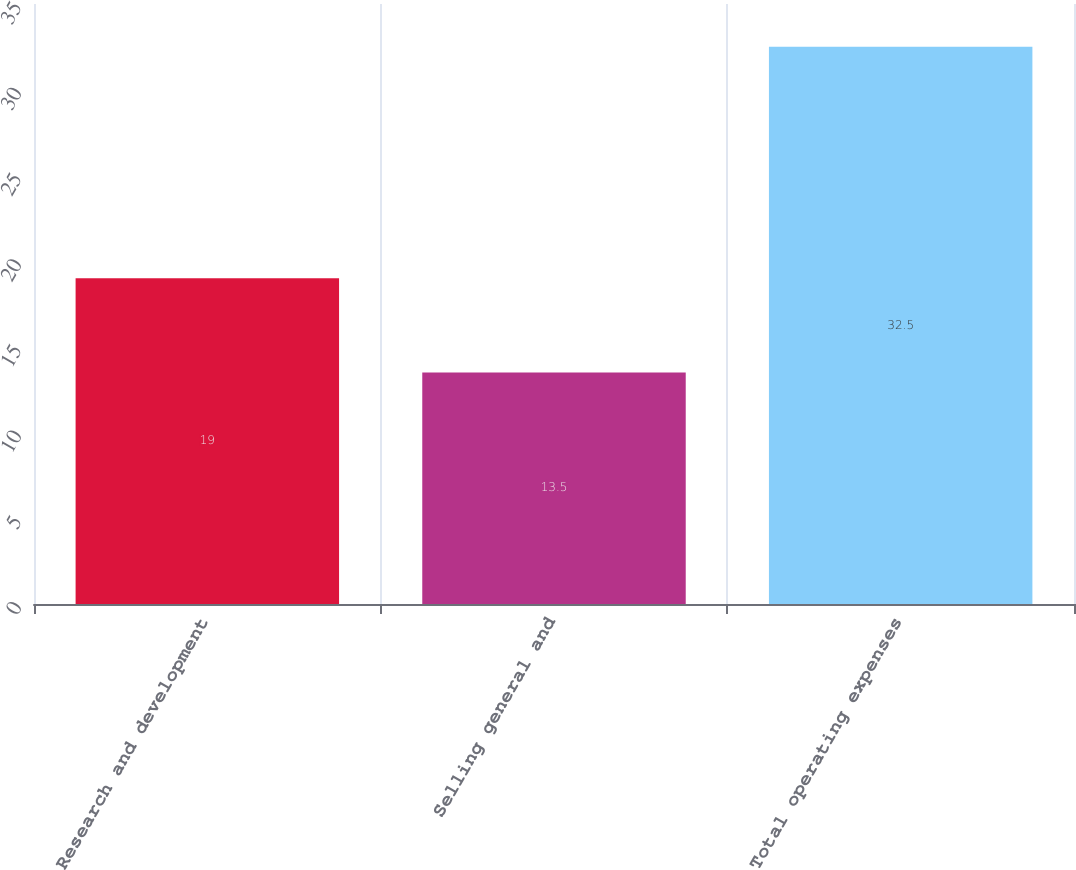Convert chart. <chart><loc_0><loc_0><loc_500><loc_500><bar_chart><fcel>Research and development<fcel>Selling general and<fcel>Total operating expenses<nl><fcel>19<fcel>13.5<fcel>32.5<nl></chart> 